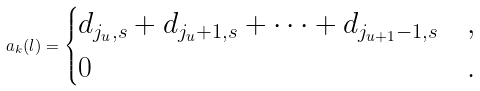Convert formula to latex. <formula><loc_0><loc_0><loc_500><loc_500>a _ { k } ( l ) = \begin{cases} d _ { j _ { u } , s } + d _ { j _ { u } + 1 , s } + \cdots + d _ { j _ { u + 1 } - 1 , s } & , \\ 0 & . \end{cases}</formula> 